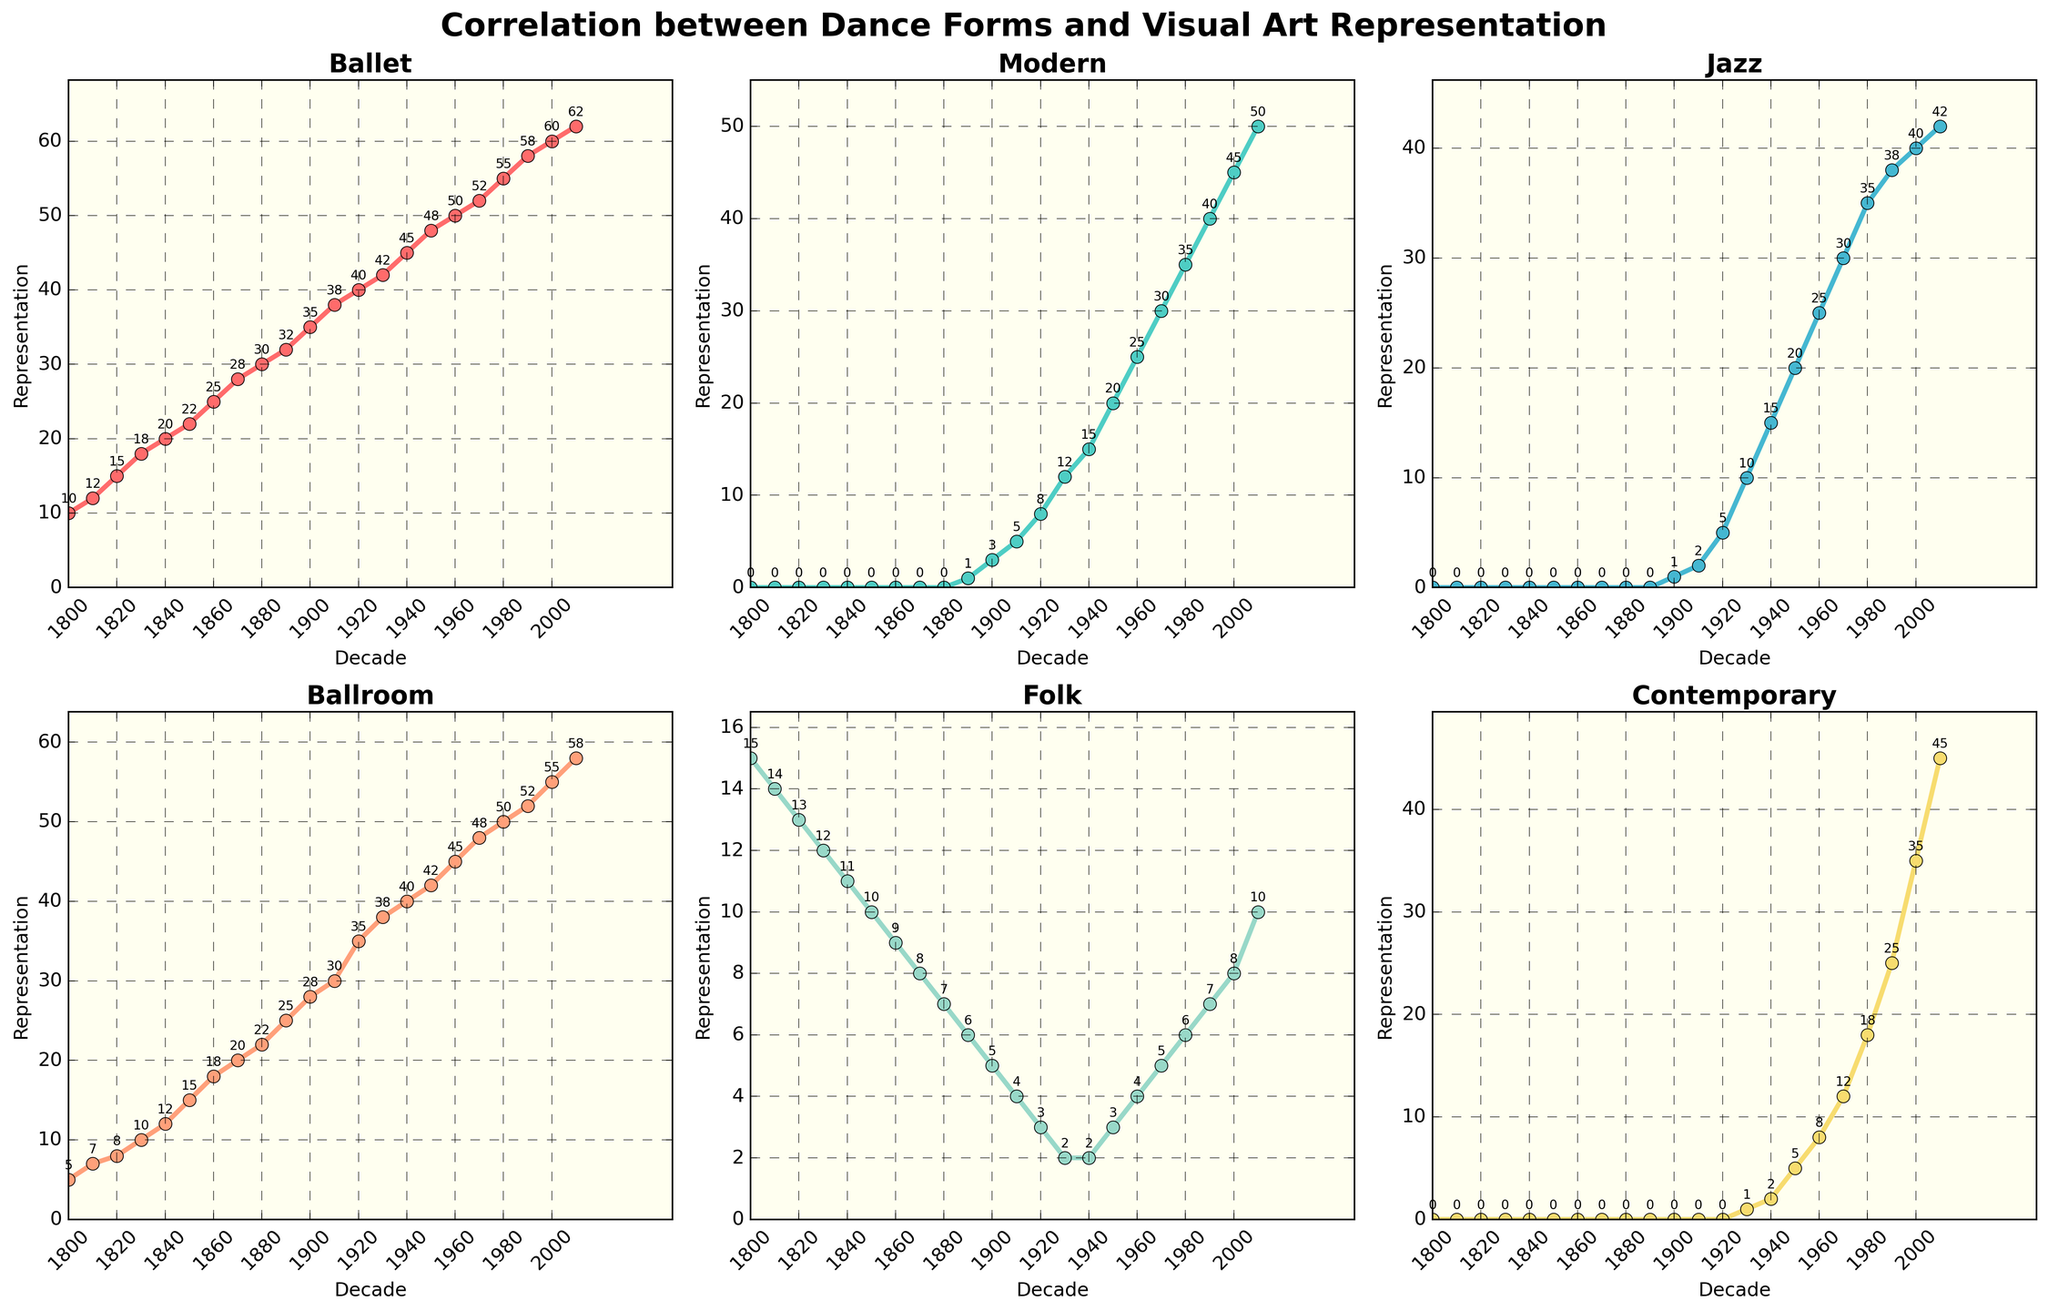What is the trend in the representation of Ballet in visual art from 1800 to 2010? From the figure, it can be seen that the line representing Ballet has a steady upward trend, starting from around 10 in 1800 and rising to 62 by 2010.
Answer: Steady increase How does the representation of Modern dance in visual art compare between 1900 and 2010? The Modern dance representation starts at 3 in 1900 and increases to 50 by 2010. This shows a significant rise over the decades.
Answer: Significant rise Between which two decades did Jazz dance see the largest increase in representation? By observing the Jazz dance subplot, it is evident that the largest increase occurs between the 1940s and 1950s where it jumps from 15 to 20, a total increase of 5 units.
Answer: 1940 to 1950 Which dance form had the highest representation in the 1920s? From the visualizations, Ballet had the highest representation in the 1920s with a value of 40, as compared to other dance forms.
Answer: Ballet What is the average representation of Folk dance in visual art from 1800 to 2010? The representation values for Folk dance are: 15, 14, 13, 12, 11, 10, 9, 8, 7, 6, 5, 4, 3, 2, 2, 3, 4, 5, 6, 7, 8, 10. Summing these gives 166, and dividing by the total number of decades (22) gives 166 / 22 = 7.54.
Answer: 7.54 Do Contemporary dance representations in visual art exceed 10 anytime before the 1980s? According to the subplot for Contemporary dance, its representation exceeds 10 only after 2010, having only minimal values before the 1980s.
Answer: No Which decade saw the introduction of Jazz dance in visual art representation? The subplot shows that Jazz dance was introduced in visual art representation in the 1900s with a value of 1.
Answer: 1900 Calculate the combined representation of Modern and Contemporary dance in the 1950s. In the 1950s, the representation of Modern dance is 20 and for Contemporary it is 5. Adding these together gives 20 + 5 = 25.
Answer: 25 